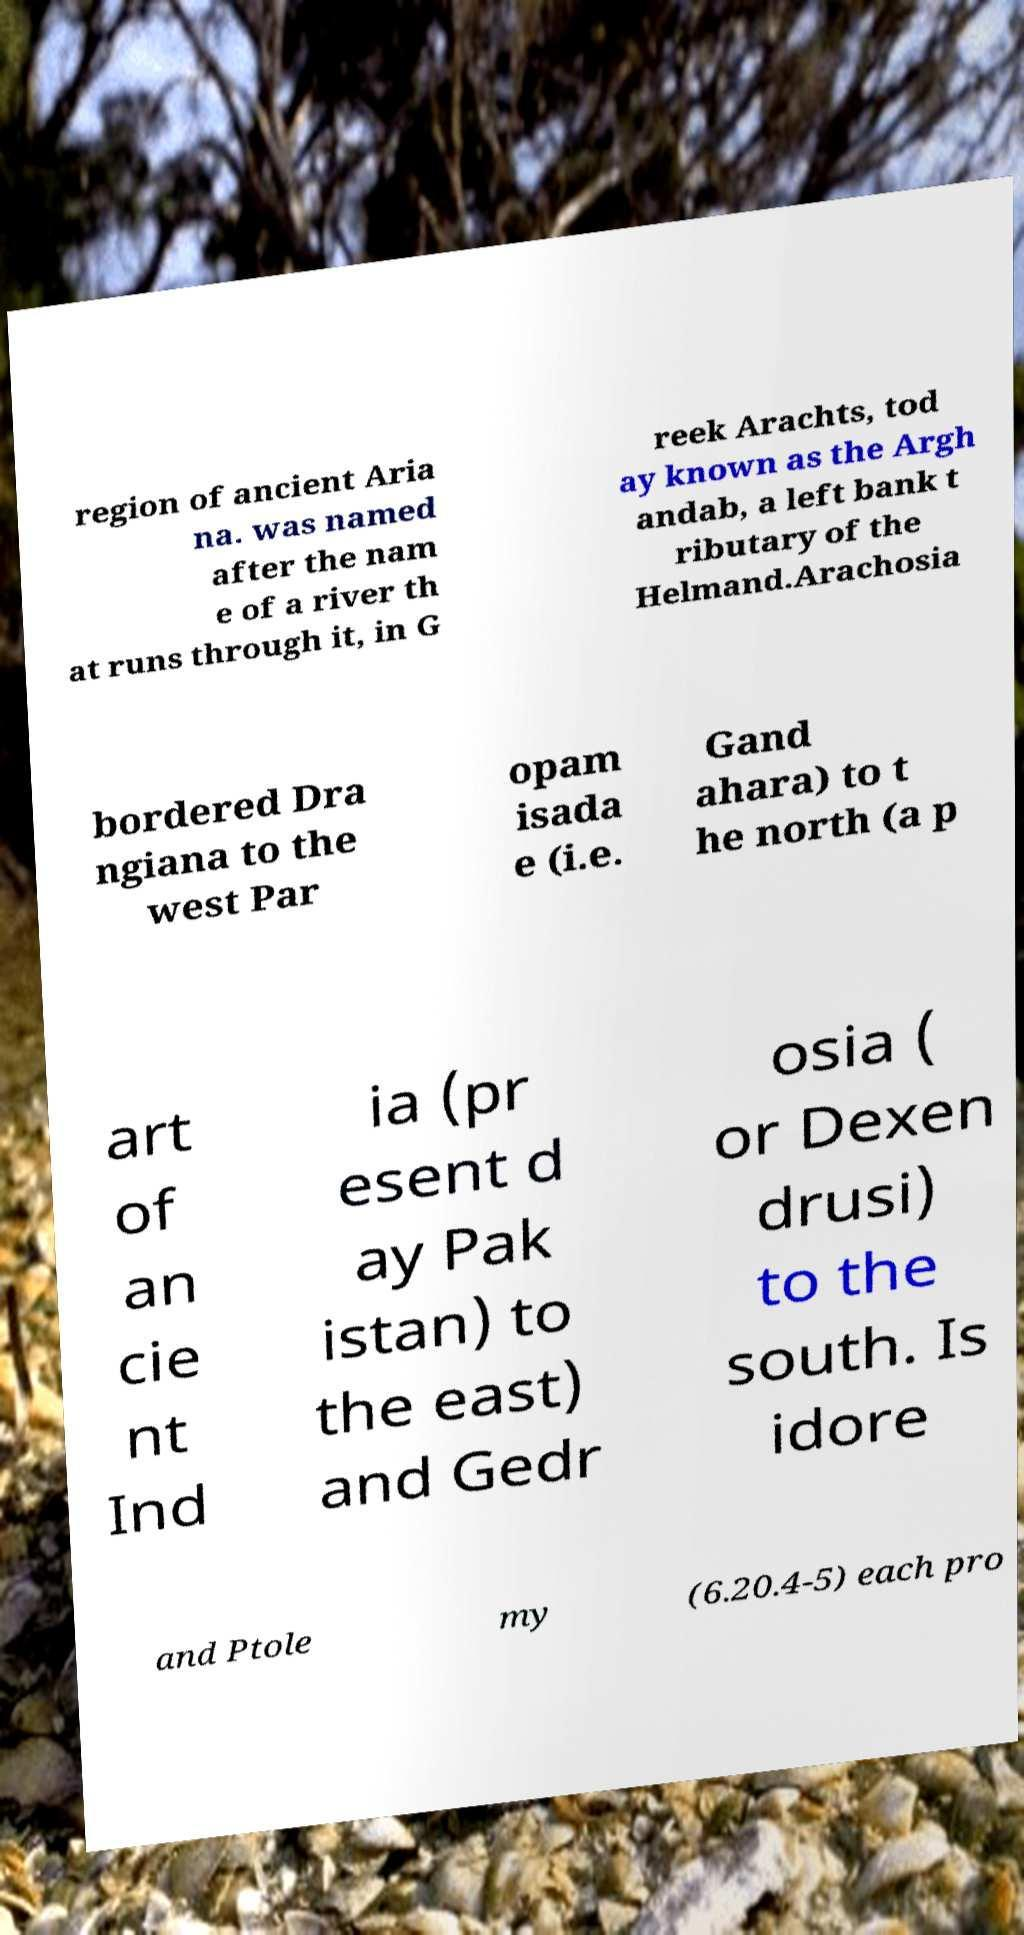There's text embedded in this image that I need extracted. Can you transcribe it verbatim? region of ancient Aria na. was named after the nam e of a river th at runs through it, in G reek Arachts, tod ay known as the Argh andab, a left bank t ributary of the Helmand.Arachosia bordered Dra ngiana to the west Par opam isada e (i.e. Gand ahara) to t he north (a p art of an cie nt Ind ia (pr esent d ay Pak istan) to the east) and Gedr osia ( or Dexen drusi) to the south. Is idore and Ptole my (6.20.4-5) each pro 